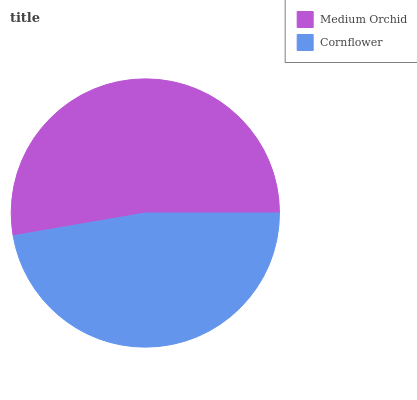Is Cornflower the minimum?
Answer yes or no. Yes. Is Medium Orchid the maximum?
Answer yes or no. Yes. Is Cornflower the maximum?
Answer yes or no. No. Is Medium Orchid greater than Cornflower?
Answer yes or no. Yes. Is Cornflower less than Medium Orchid?
Answer yes or no. Yes. Is Cornflower greater than Medium Orchid?
Answer yes or no. No. Is Medium Orchid less than Cornflower?
Answer yes or no. No. Is Medium Orchid the high median?
Answer yes or no. Yes. Is Cornflower the low median?
Answer yes or no. Yes. Is Cornflower the high median?
Answer yes or no. No. Is Medium Orchid the low median?
Answer yes or no. No. 